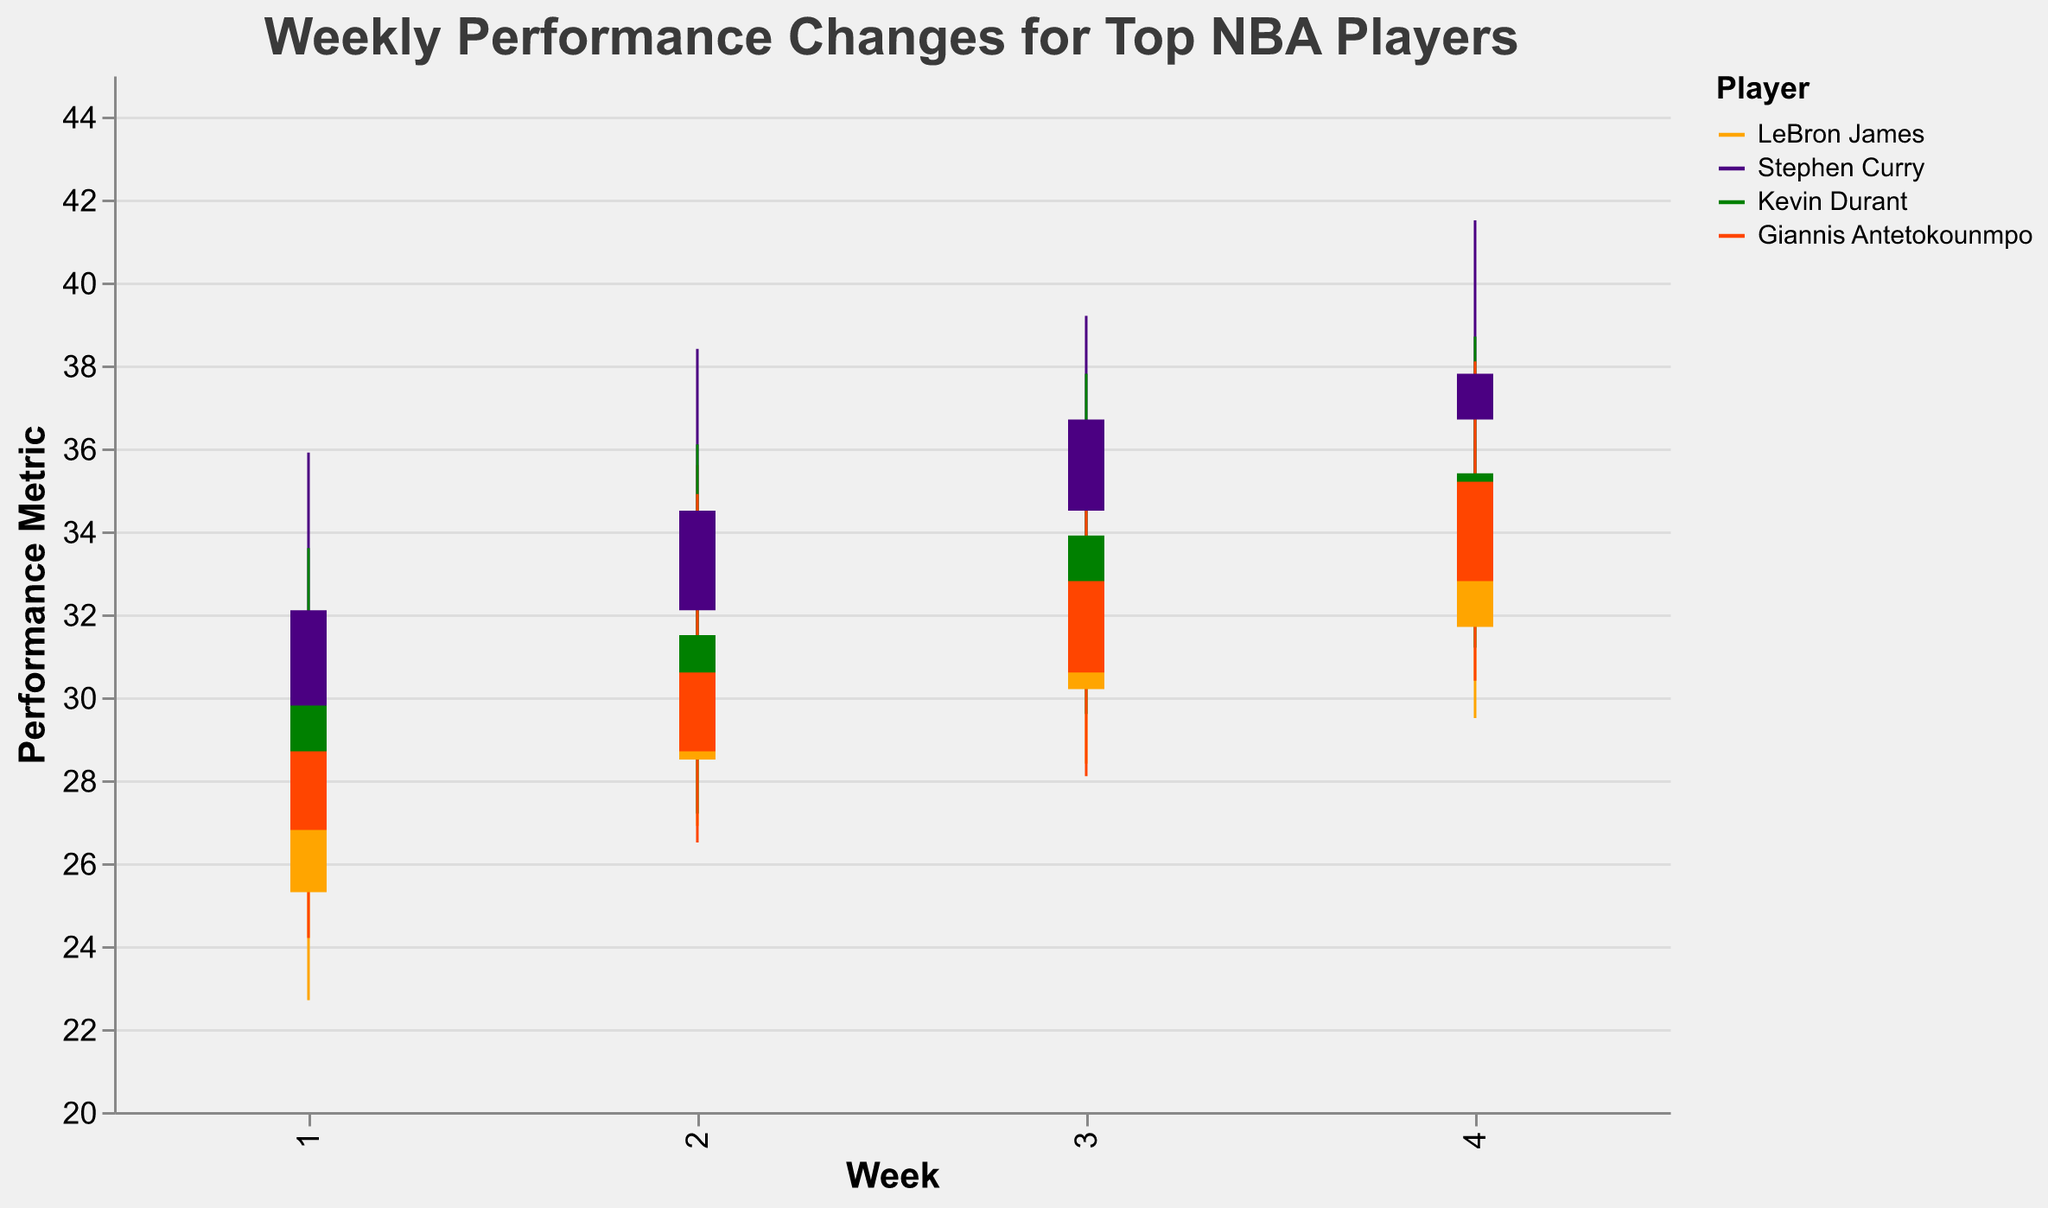What's the title of the chart? The title of the chart is displayed prominently at the top of the figure. It reads "Weekly Performance Changes for Top NBA Players".
Answer: Weekly Performance Changes for Top NBA Players Which player had the highest "Close" value in Week 4? To determine this, we need to look at the "Close" values for each player in Week 4 and identify the highest one. LeBron James had 34.8, Stephen Curry had 37.8, Kevin Durant had 35.4, and Giannis Antetokounmpo had 35.2. Stephen Curry had the highest "Close" value.
Answer: Stephen Curry What is LeBron James's lowest performance metric in Week 3? LeBron James's performance metrics for Week 3 are depicted by the "Low" value in the respective OHLC bar. According to the data, it is 28.4.
Answer: 28.4 Whose performance improved the most between Week 1 and Week 4? To find out the performance improvement, compare the "Close" values between Week 1 and Week 4 for each player. Calculate the increase: LeBron James (34.8 - 28.5 = 6.3), Stephen Curry (37.8 - 32.1 = 5.7), Kevin Durant (35.4 - 29.8 = 5.6), Giannis Antetokounmpo (35.2 - 28.7 = 6.5). Giannis Antetokounmpo shows the highest improvement.
Answer: Giannis Antetokounmpo For which player is the difference between the highest and lowest performance metrics for Week 2 the greatest? Calculate the range (High - Low) for Week 2 for each player: LeBron James (35.6 - 26.9 = 8.7), Stephen Curry (38.4 - 30.7 = 7.7), Kevin Durant (36.1 - 27.2 = 8.9), Giannis Antetokounmpo (34.9 - 26.5 = 8.4). Kevin Durant has the greatest range of 8.9.
Answer: Kevin Durant How many players had their "Close" values increase from Week 1 to Week 2? Check each player's "Close" values for Week 1 and Week 2: LeBron James (28.5 to 30.2, increase), Stephen Curry (32.1 to 34.5, increase), Kevin Durant (29.8 to 31.5, increase), Giannis Antetokounmpo (28.7 to 30.6, increase). All four players had their "Close" values increase.
Answer: Four Which week did Stephen Curry have the highest "High" value? Stephen Curry's "High" values for each week are: Week 1 (35.9), Week 2 (38.4), Week 3 (39.2), Week 4 (41.5). The highest "High" value is in Week 4 with 41.5.
Answer: Week 4 